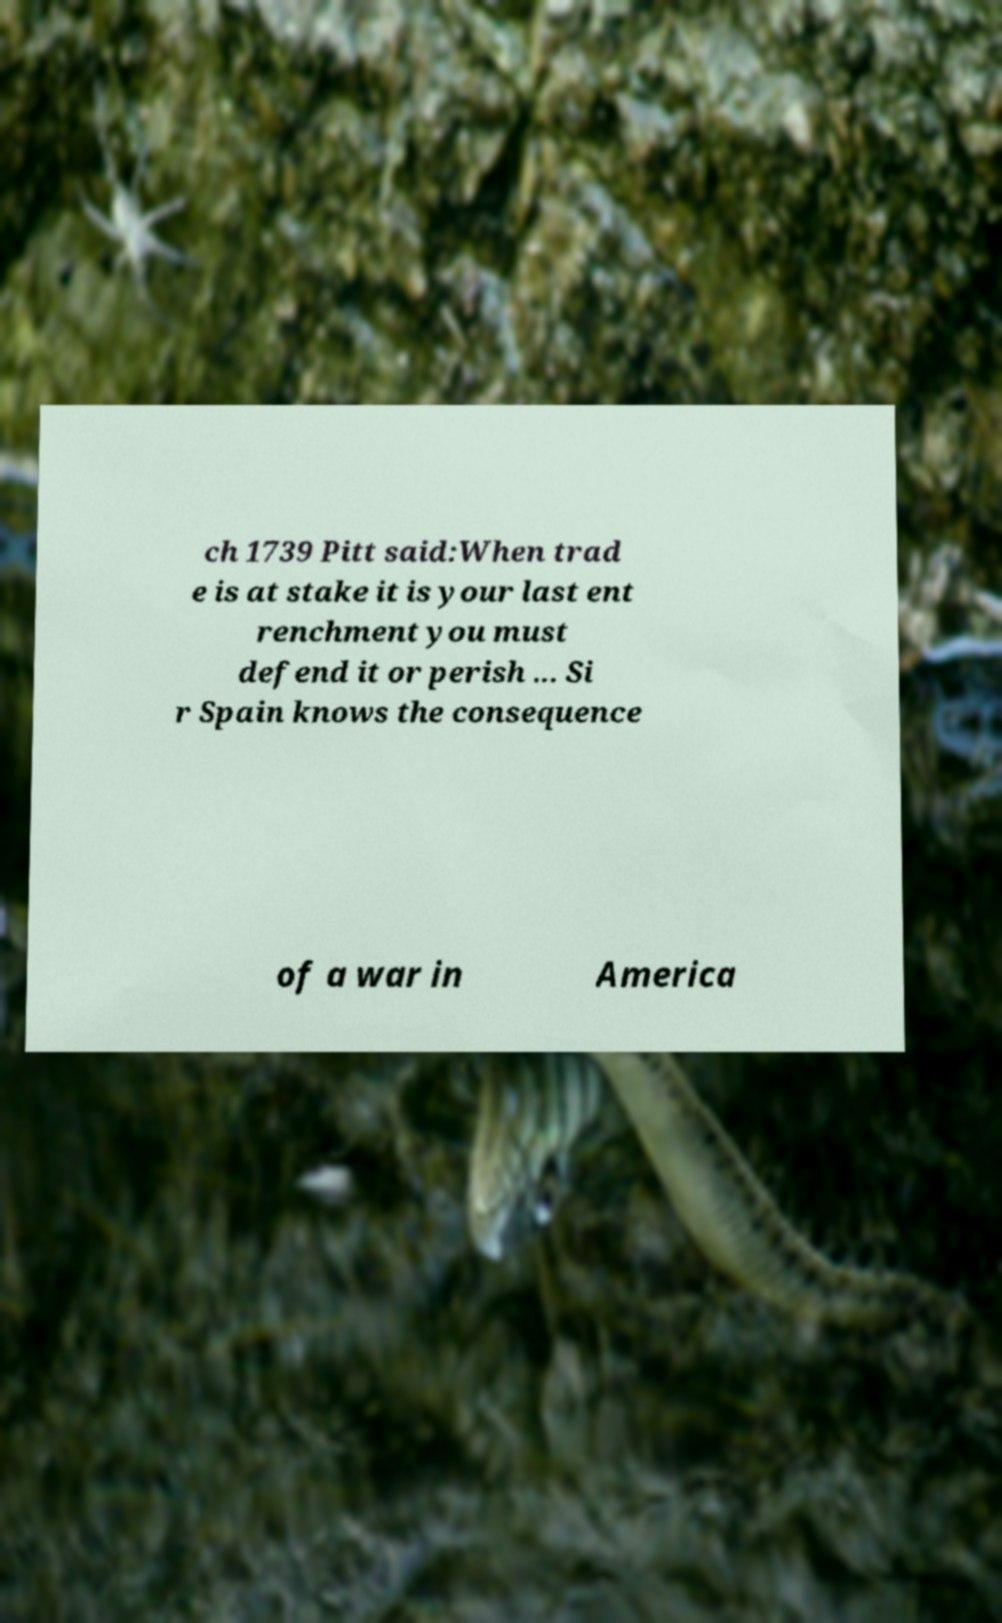Can you read and provide the text displayed in the image?This photo seems to have some interesting text. Can you extract and type it out for me? ch 1739 Pitt said:When trad e is at stake it is your last ent renchment you must defend it or perish ... Si r Spain knows the consequence of a war in America 